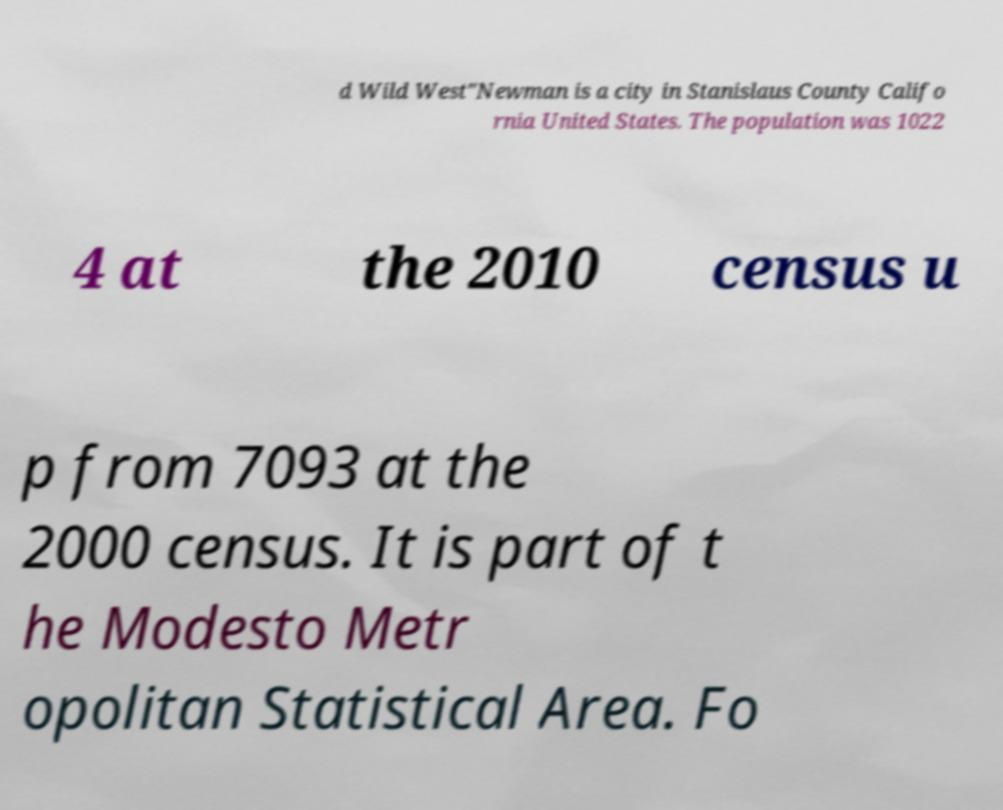Can you accurately transcribe the text from the provided image for me? d Wild West"Newman is a city in Stanislaus County Califo rnia United States. The population was 1022 4 at the 2010 census u p from 7093 at the 2000 census. It is part of t he Modesto Metr opolitan Statistical Area. Fo 